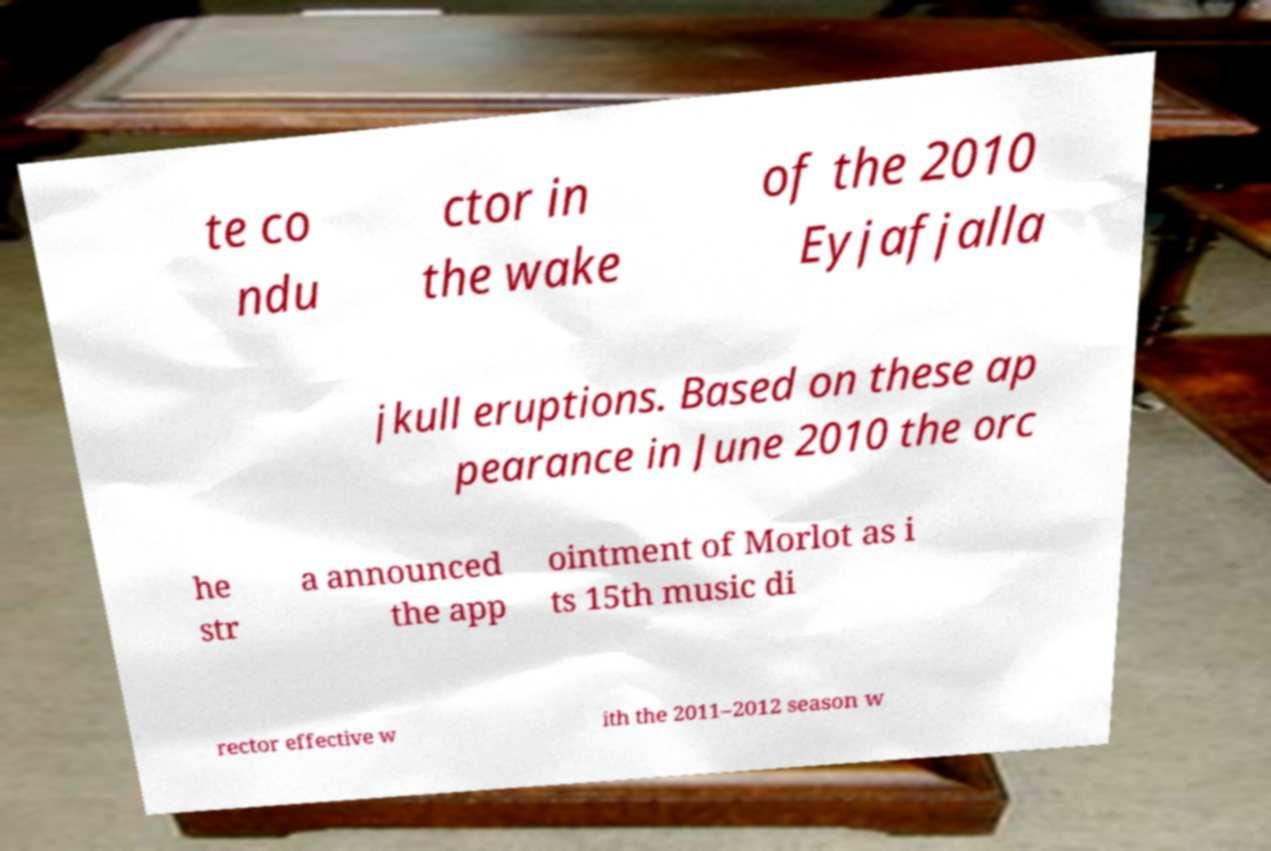Can you accurately transcribe the text from the provided image for me? te co ndu ctor in the wake of the 2010 Eyjafjalla jkull eruptions. Based on these ap pearance in June 2010 the orc he str a announced the app ointment of Morlot as i ts 15th music di rector effective w ith the 2011–2012 season w 